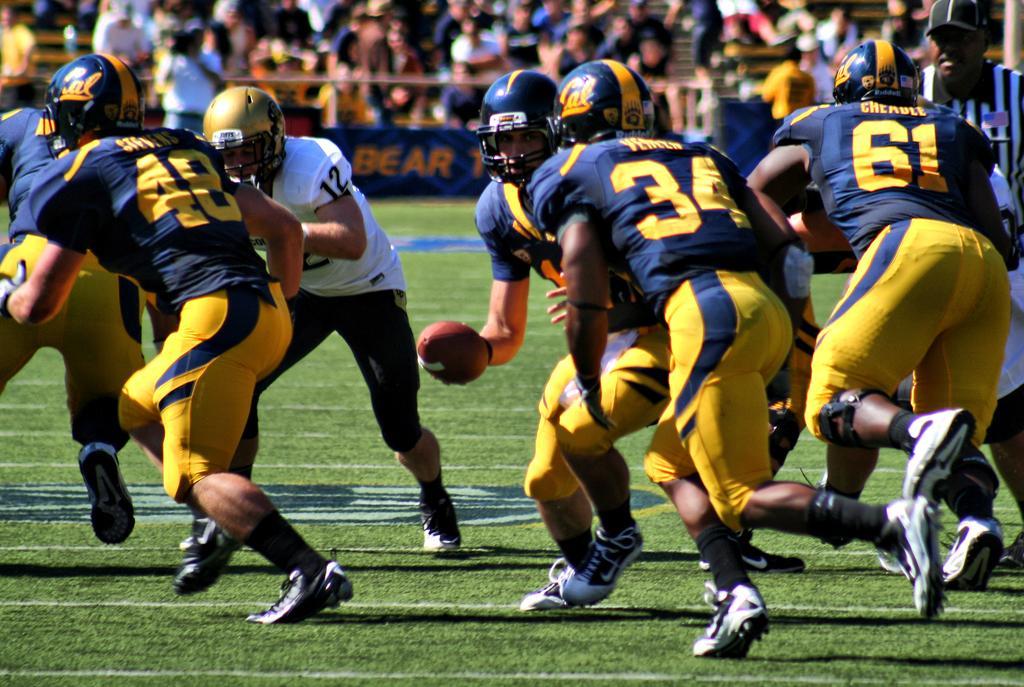In one or two sentences, can you explain what this image depicts? In this image we can see a few people, some of them are playing an American football, one of them is holding a ball, we can see a banner with some text on it, and the background is blurred. 